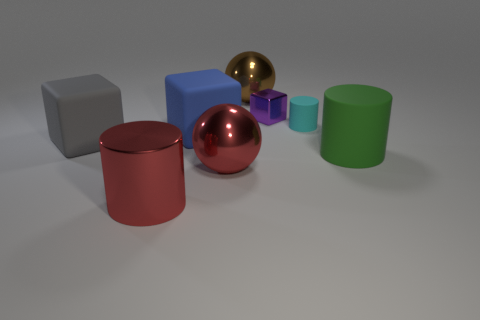The rubber thing that is in front of the gray matte object in front of the cyan thing is what shape?
Provide a short and direct response. Cylinder. How many other objects are there of the same color as the big rubber cylinder?
Offer a terse response. 0. Do the ball behind the gray cube and the cylinder that is in front of the big green matte cylinder have the same material?
Ensure brevity in your answer.  Yes. There is a cylinder behind the big gray rubber thing; what is its size?
Your answer should be very brief. Small. There is a purple object that is the same shape as the big gray matte thing; what is it made of?
Your response must be concise. Metal. Is there any other thing that is the same size as the blue matte block?
Keep it short and to the point. Yes. There is a rubber thing behind the blue matte thing; what shape is it?
Your response must be concise. Cylinder. How many red shiny objects have the same shape as the cyan object?
Your answer should be compact. 1. Are there an equal number of spheres that are on the right side of the big green matte cylinder and green cylinders that are to the right of the small matte thing?
Your answer should be compact. No. Is there a small purple block made of the same material as the big red sphere?
Your answer should be compact. Yes. 